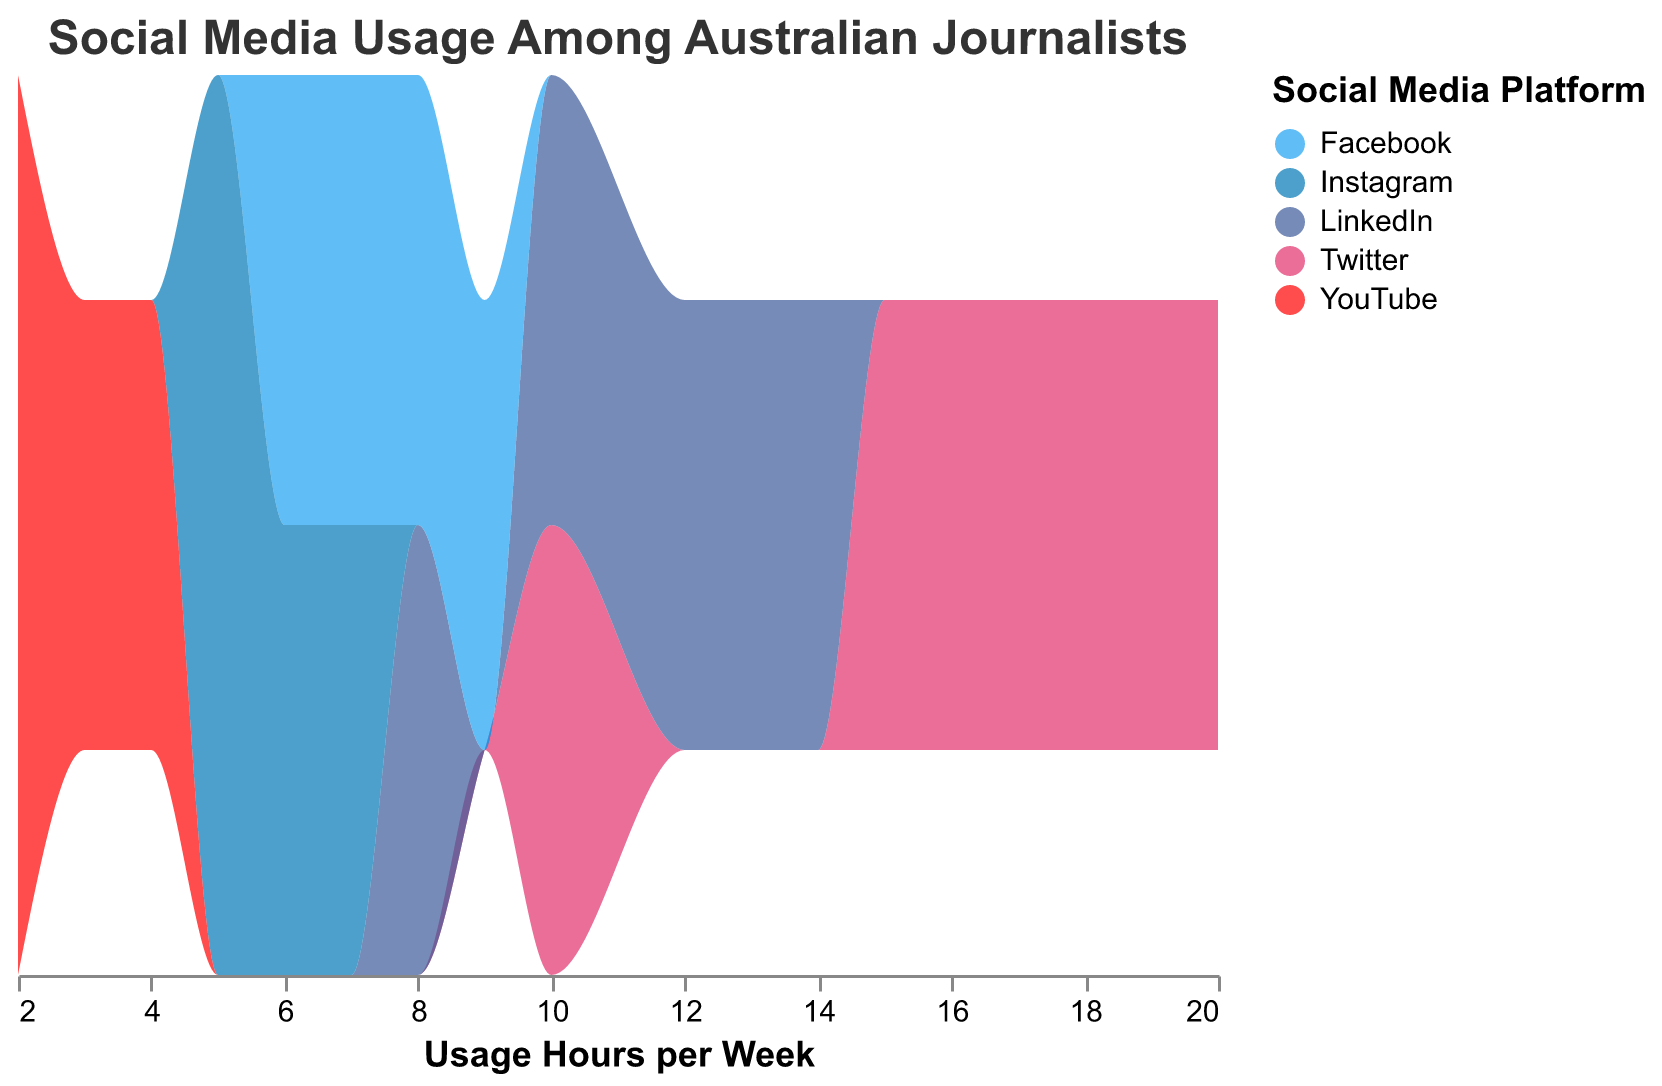What is the title of the figure? The title of the figure is at the top and clearly states the purpose of the visual. It reads "Social Media Usage Among Australian Journalists".
Answer: Social Media Usage Among Australian Journalists How many platforms are represented in the density plot? Look at the legend that categorizes the different social media platforms. There are five colors, each corresponding to a platform.
Answer: Five Which social media platform has the highest peak usage? Find the highest peak areas within each color band. Twitter (colored in blue) reaches the highest peak compared to other platforms.
Answer: Twitter What is the range of usage hours for Instagram? Look at the x-axis under the pink shaded area (Instagram). It spans from 5 to 7 usage hours per week.
Answer: 5 to 7 hours per week Which social media platform has the widest range of usage hours? Compare the span on the x-axis for each color band. Twitter spans from 10 to 20 hours, which is the widest range.
Answer: Twitter How does the usage pattern for LinkedIn compare to Facebook? Compare the light blue band (LinkedIn) and dark blue band (Facebook). LinkedIn ranges from 8 to 14 hours, peaking around 12 hours. Facebook ranges from 6 to 9 hours, peaking around 7 hours. LinkedIn's usage range is wider, with a higher peak.
Answer: LinkedIn has a wider range and a slightly higher peak What is the combined range of usage hours for all platforms? Find the minimum and maximum usage hours from all color bands combined. The minimum is 2 hours (YouTube) and the maximum is 20 hours (Twitter).
Answer: 2 to 20 hours per week Which platform shows the least variation in usage hours? Look for the most compact color band. YouTube (red) ranges from 2 to 4 hours, showing the least variation.
Answer: YouTube At what usage hours does LinkedIn reach its peak? The light blue band (LinkedIn) peaks at the highest point around the 12 hours mark on the x-axis.
Answer: 12 hours per week How many platforms have their peaks below 10 hours of usage per week? Count the peaks of each color band below the 10 hours mark. Facebook, Instagram, YouTube, and LinkedIn each peak below 10 hours.
Answer: Four platforms 